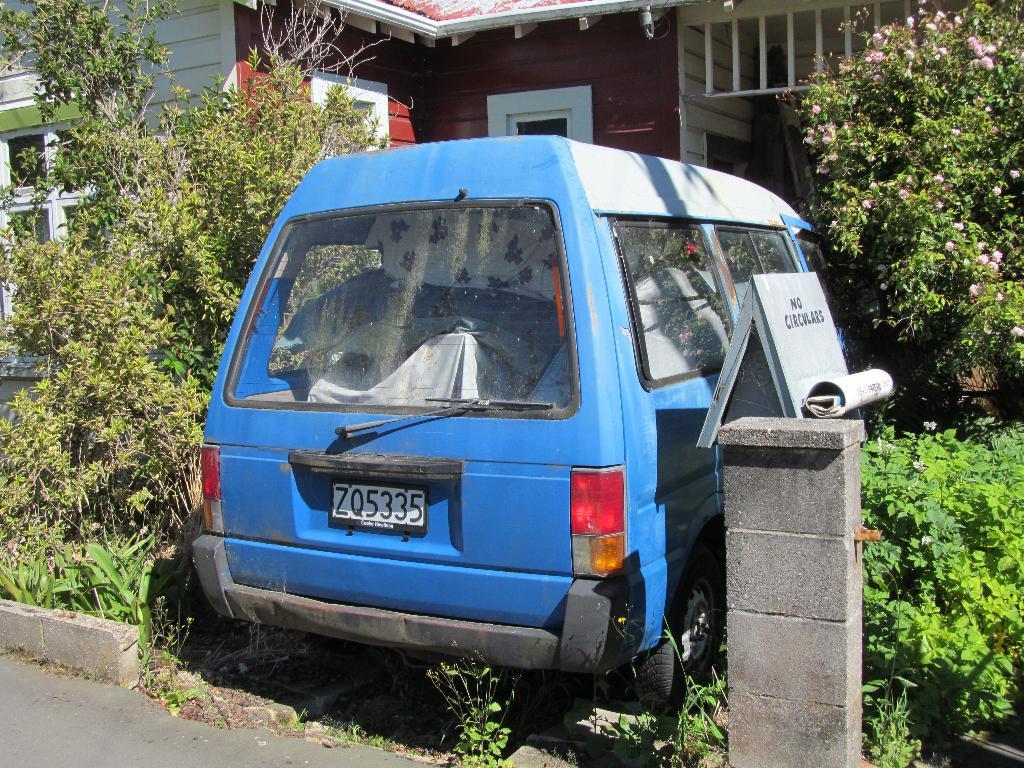What is the license plate number?
Keep it short and to the point. Zq5335. What color is the van?
Ensure brevity in your answer.  Blue. 